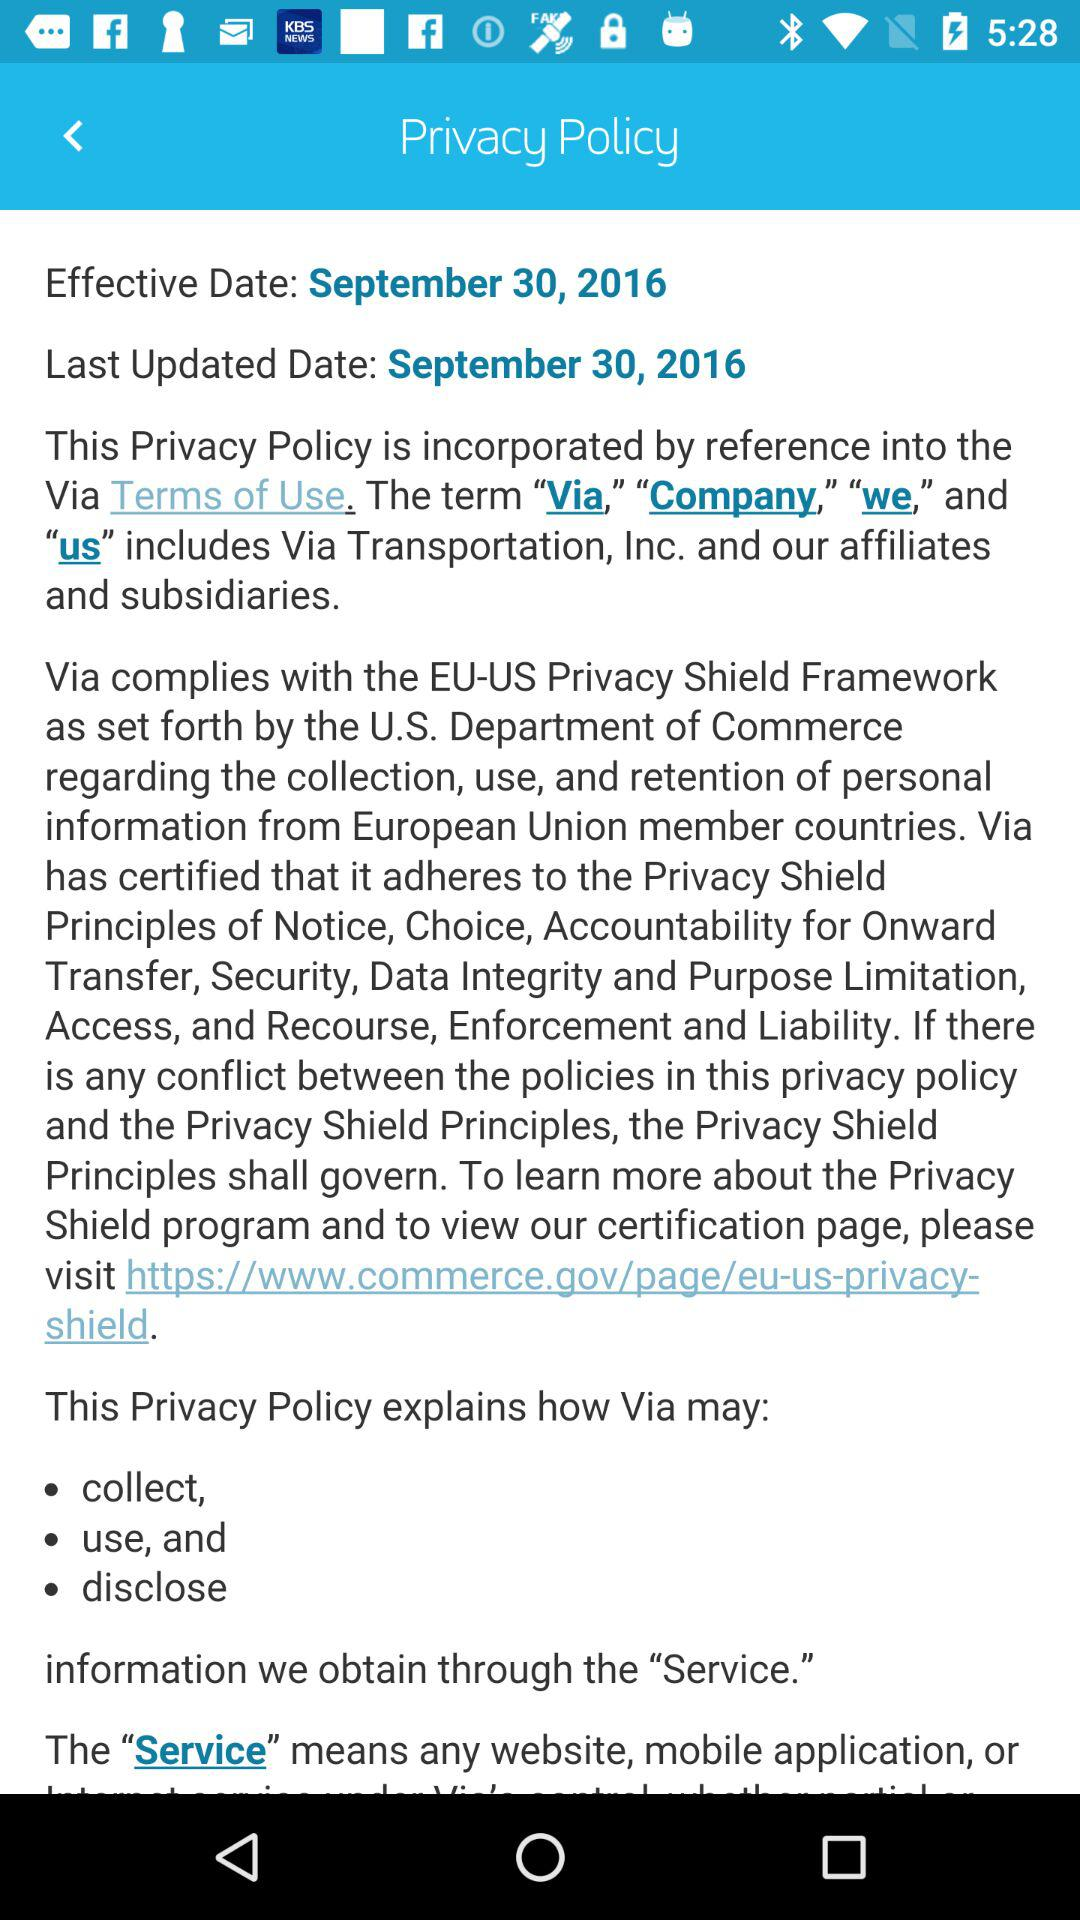When did the privacy policy last get updated? The privacy policy was last updated on September 30, 2016. 